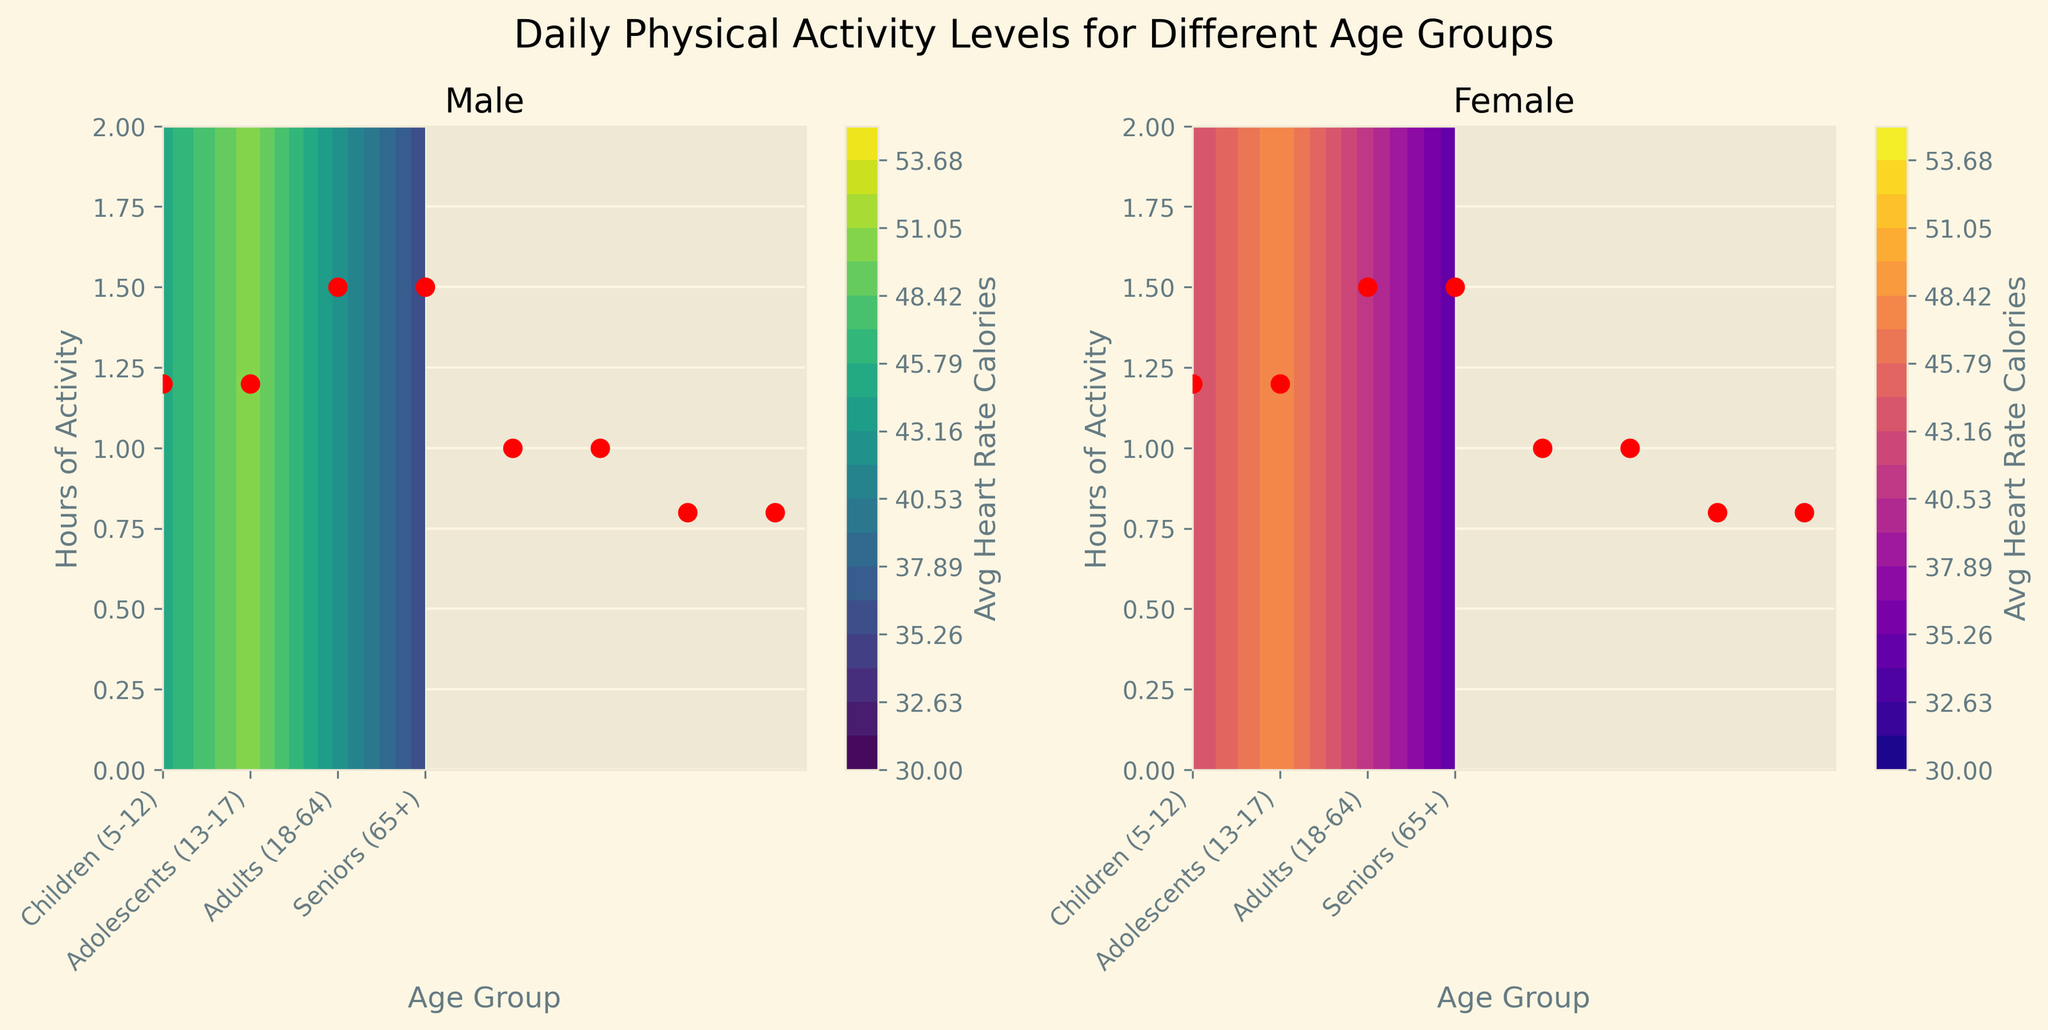What is the title of the figure? The title is usually at the top of the figure. It provides a brief description of what the graph represents. In this case, it's "Daily Physical Activity Levels for Different Age Groups".
Answer: Daily Physical Activity Levels for Different Age Groups How many age groups are represented in the figure? Count the unique age groups on the x-axis. The labels on the x-axis are 'Children (5-12)', 'Adolescents (13-17)', 'Adults (18-64)', and 'Seniors (65+)'.
Answer: 4 Which contour plot shows higher average heart rate calories for males? Compare the color gradients of both contour plots. In general, compare the color legends for each plot. The male plot (viridis) shows higher average heart rate calories for a given range.
Answer: Male In which age group do males have a higher average heart rate calorie consumption than females? Look for the average values in relevant color gradients for each age group in both contour plots. In each age group, compare the calorie levels. Males show higher calorie consumption across all age groups.
Answer: All age groups Which age group shows the lowest average heart rate calories for females? Identify the darkest regions or the lowest subscripts in the color bar for the female contour plot. Seniors (65+) have the lowest average heart rate calories for females where it is reflected in the darkest regions.
Answer: Seniors (65+) How do the average heart rate calories compare between adults' males and females? Observe and compare the shade of colors specific to adults (18-64) in both contour plots. The colors in the male plot are slightly lighter than the corresponding colors in the female plot, indicating males have higher avg heart rate calories by a small margin.
Answer: Males higher How does the hour of activity affect average heart rate calories within gender groups? Observe the color gradient along the y-axis (Hours of Activity) within each individual subplot to see if color intensity changes significantly. The plots show that hours of activity do not significantly change the avg heart rate calories in the contour maps.
Answer: No significant change Which gender shows more variability in average heart rate calories across age groups? Evaluate the color variations across different age groups within both contour plots. The male plot shows more variation as the colors in the female plot are closer in shade across age groups, especially in seniors.
Answer: Male What is the range of the color bar in the female contour plot? Examine the color bar legend next to the female contour plot to identify the range of average heart rate calories. The range is indicated from 30 to 55.
Answer: 30 to 55 